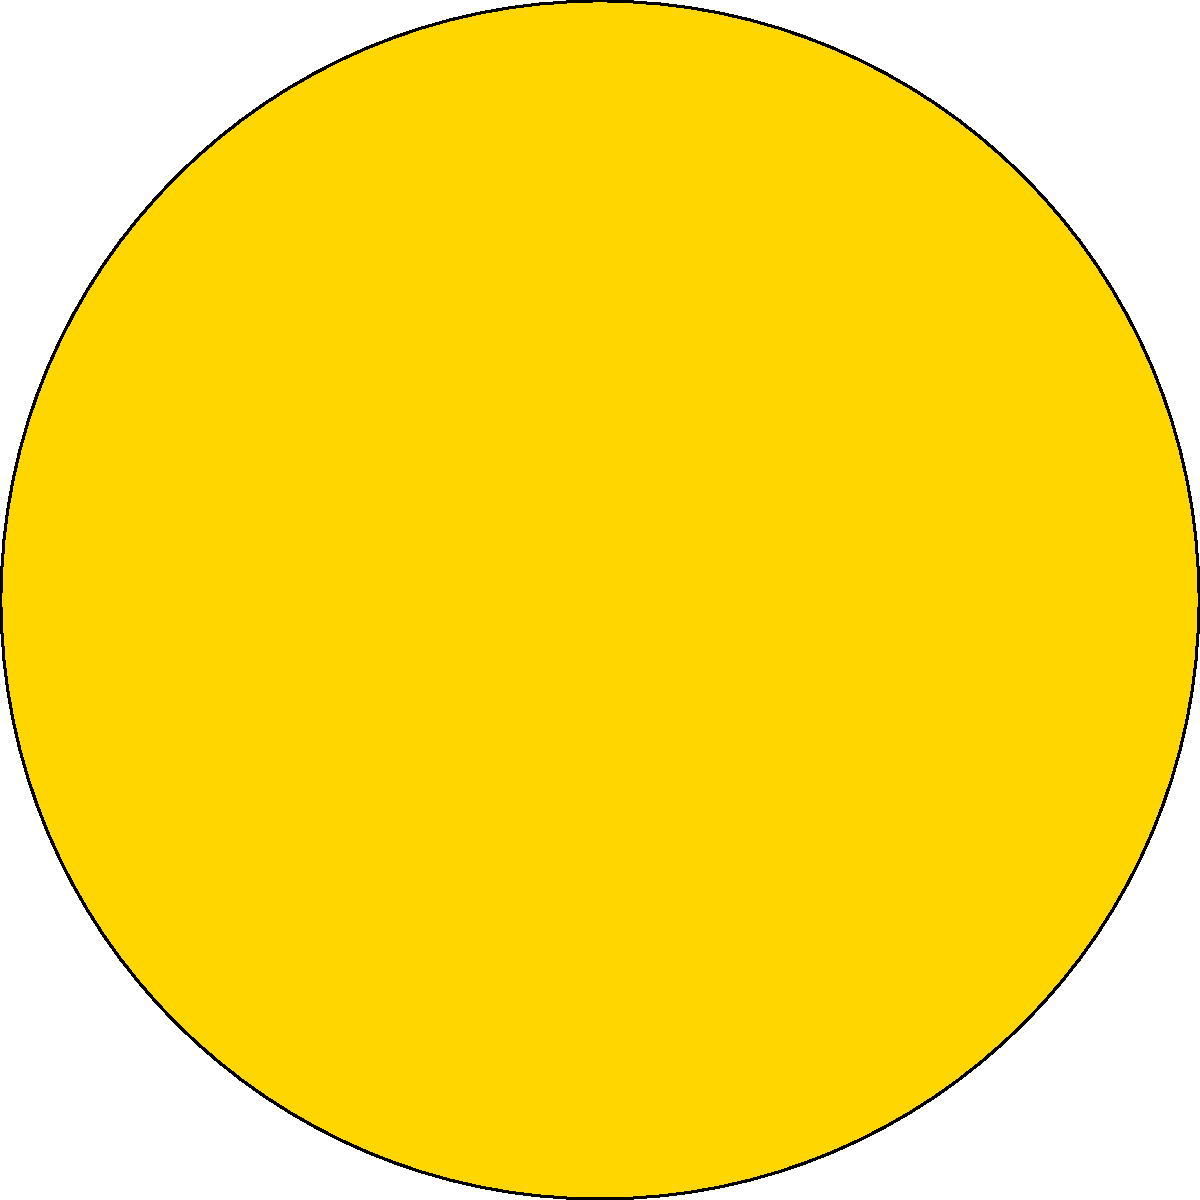As you plan your grand concert tour, you're presented with a color-coded seating chart for ticket pricing. If you want to maximize revenue while ensuring at least 60% of the seats are priced at $200 or less, what's the minimum number of sections you should include in your seating arrangement? Let's approach this step-by-step:

1. Analyze the seating chart:
   - VIP (Gold): Center circle
   - Section A (Silver): First ring
   - Section B (Bronze): Second ring
   - Section C (Regular): Outer ring

2. Consider the pricing:
   - VIP: $500
   - A: $300
   - B: $200
   - C: $100

3. To ensure at least 60% of seats are priced at $200 or less, we need to include sections B and C at minimum.

4. Let's consider the options:
   a) Only C: This would be 100% at $100, but wouldn't maximize revenue.
   b) B and C: This would likely be more than 60% at $200 or less, and includes a higher-priced option.
   c) A, B, and C: This adds an even higher-priced option, potentially maximizing revenue while still keeping a significant portion at $200 or less.
   d) VIP, A, B, and C: This includes all sections, but might reduce the percentage of seats at $200 or less below 60%.

5. Option c (A, B, and C) is likely the best balance, as it includes three pricing tiers while still keeping a majority of seats at $200 or less.

Therefore, the minimum number of sections to include while meeting the criteria is 3: A, B, and C.
Answer: 3 sections 